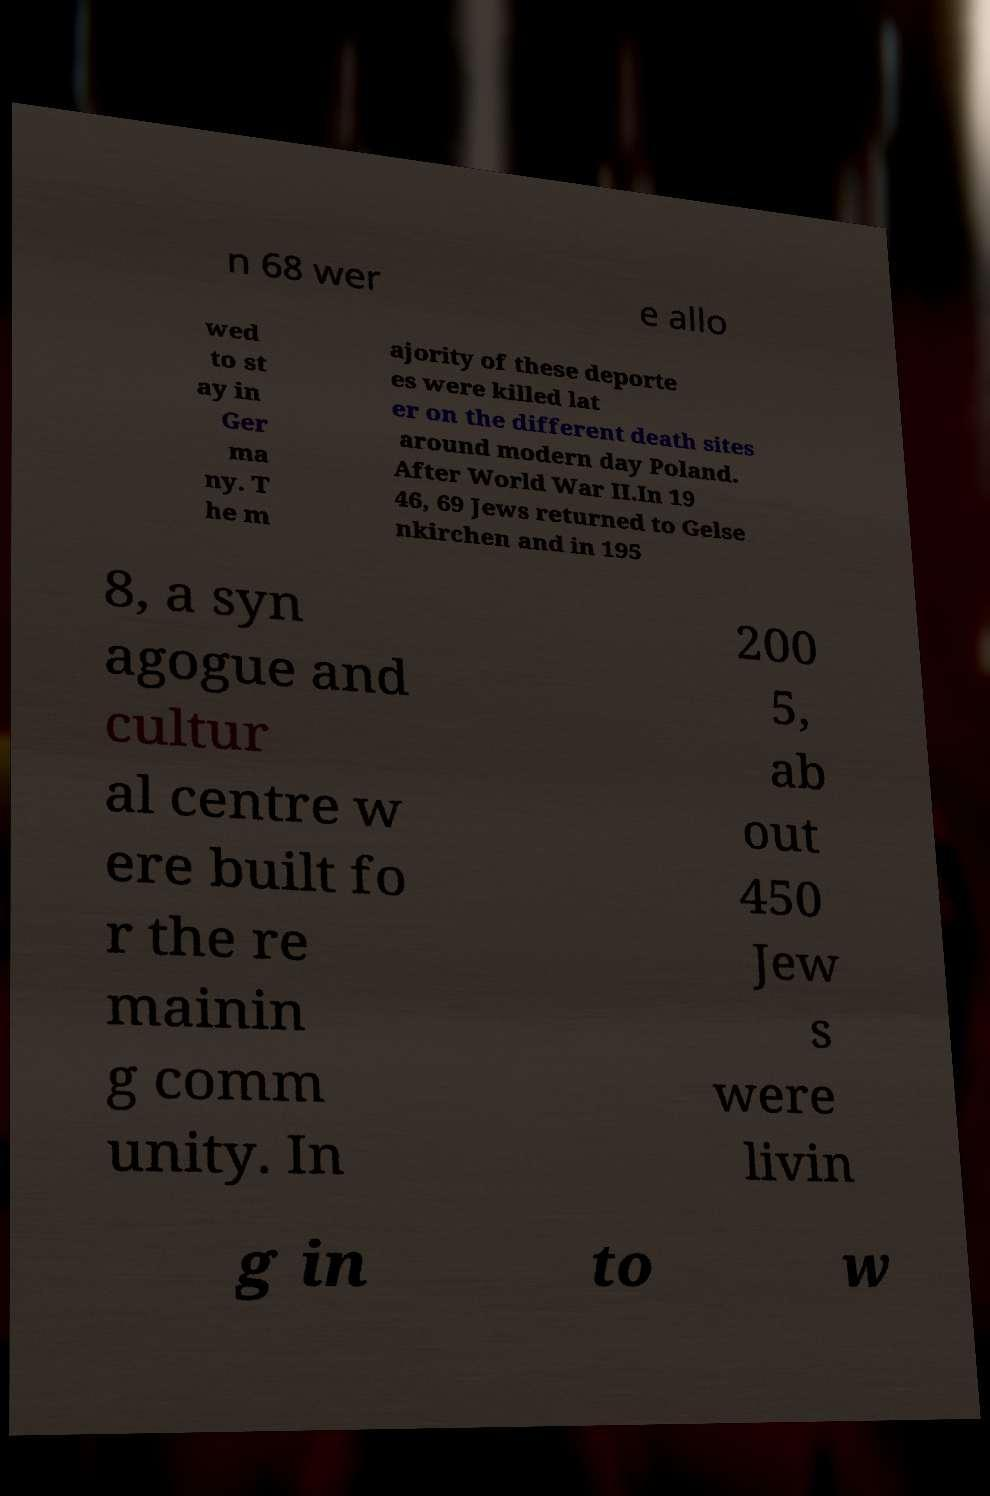Can you read and provide the text displayed in the image?This photo seems to have some interesting text. Can you extract and type it out for me? n 68 wer e allo wed to st ay in Ger ma ny. T he m ajority of these deporte es were killed lat er on the different death sites around modern day Poland. After World War II.In 19 46, 69 Jews returned to Gelse nkirchen and in 195 8, a syn agogue and cultur al centre w ere built fo r the re mainin g comm unity. In 200 5, ab out 450 Jew s were livin g in to w 